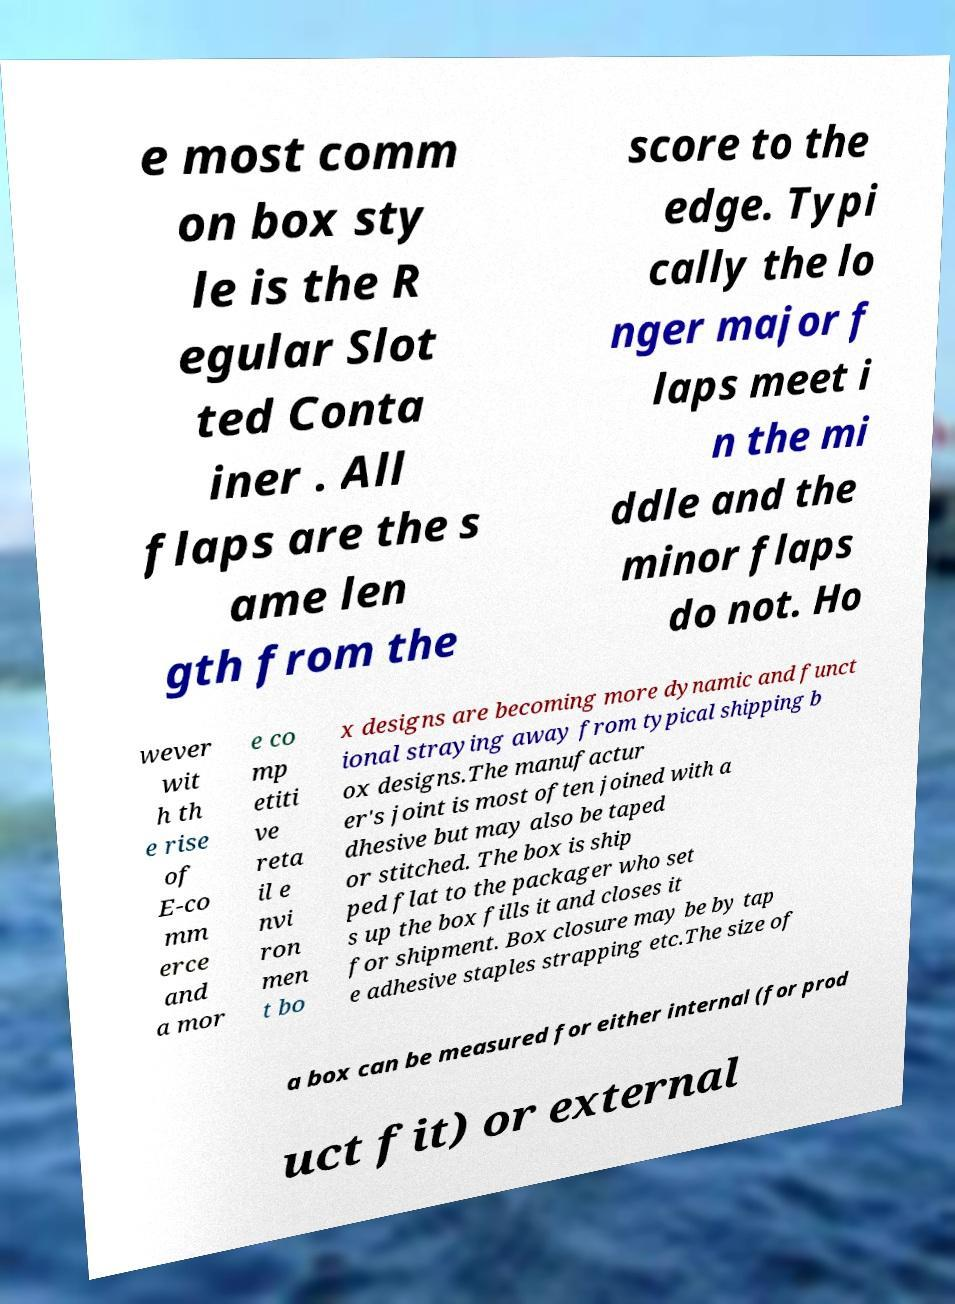There's text embedded in this image that I need extracted. Can you transcribe it verbatim? e most comm on box sty le is the R egular Slot ted Conta iner . All flaps are the s ame len gth from the score to the edge. Typi cally the lo nger major f laps meet i n the mi ddle and the minor flaps do not. Ho wever wit h th e rise of E-co mm erce and a mor e co mp etiti ve reta il e nvi ron men t bo x designs are becoming more dynamic and funct ional straying away from typical shipping b ox designs.The manufactur er's joint is most often joined with a dhesive but may also be taped or stitched. The box is ship ped flat to the packager who set s up the box fills it and closes it for shipment. Box closure may be by tap e adhesive staples strapping etc.The size of a box can be measured for either internal (for prod uct fit) or external 